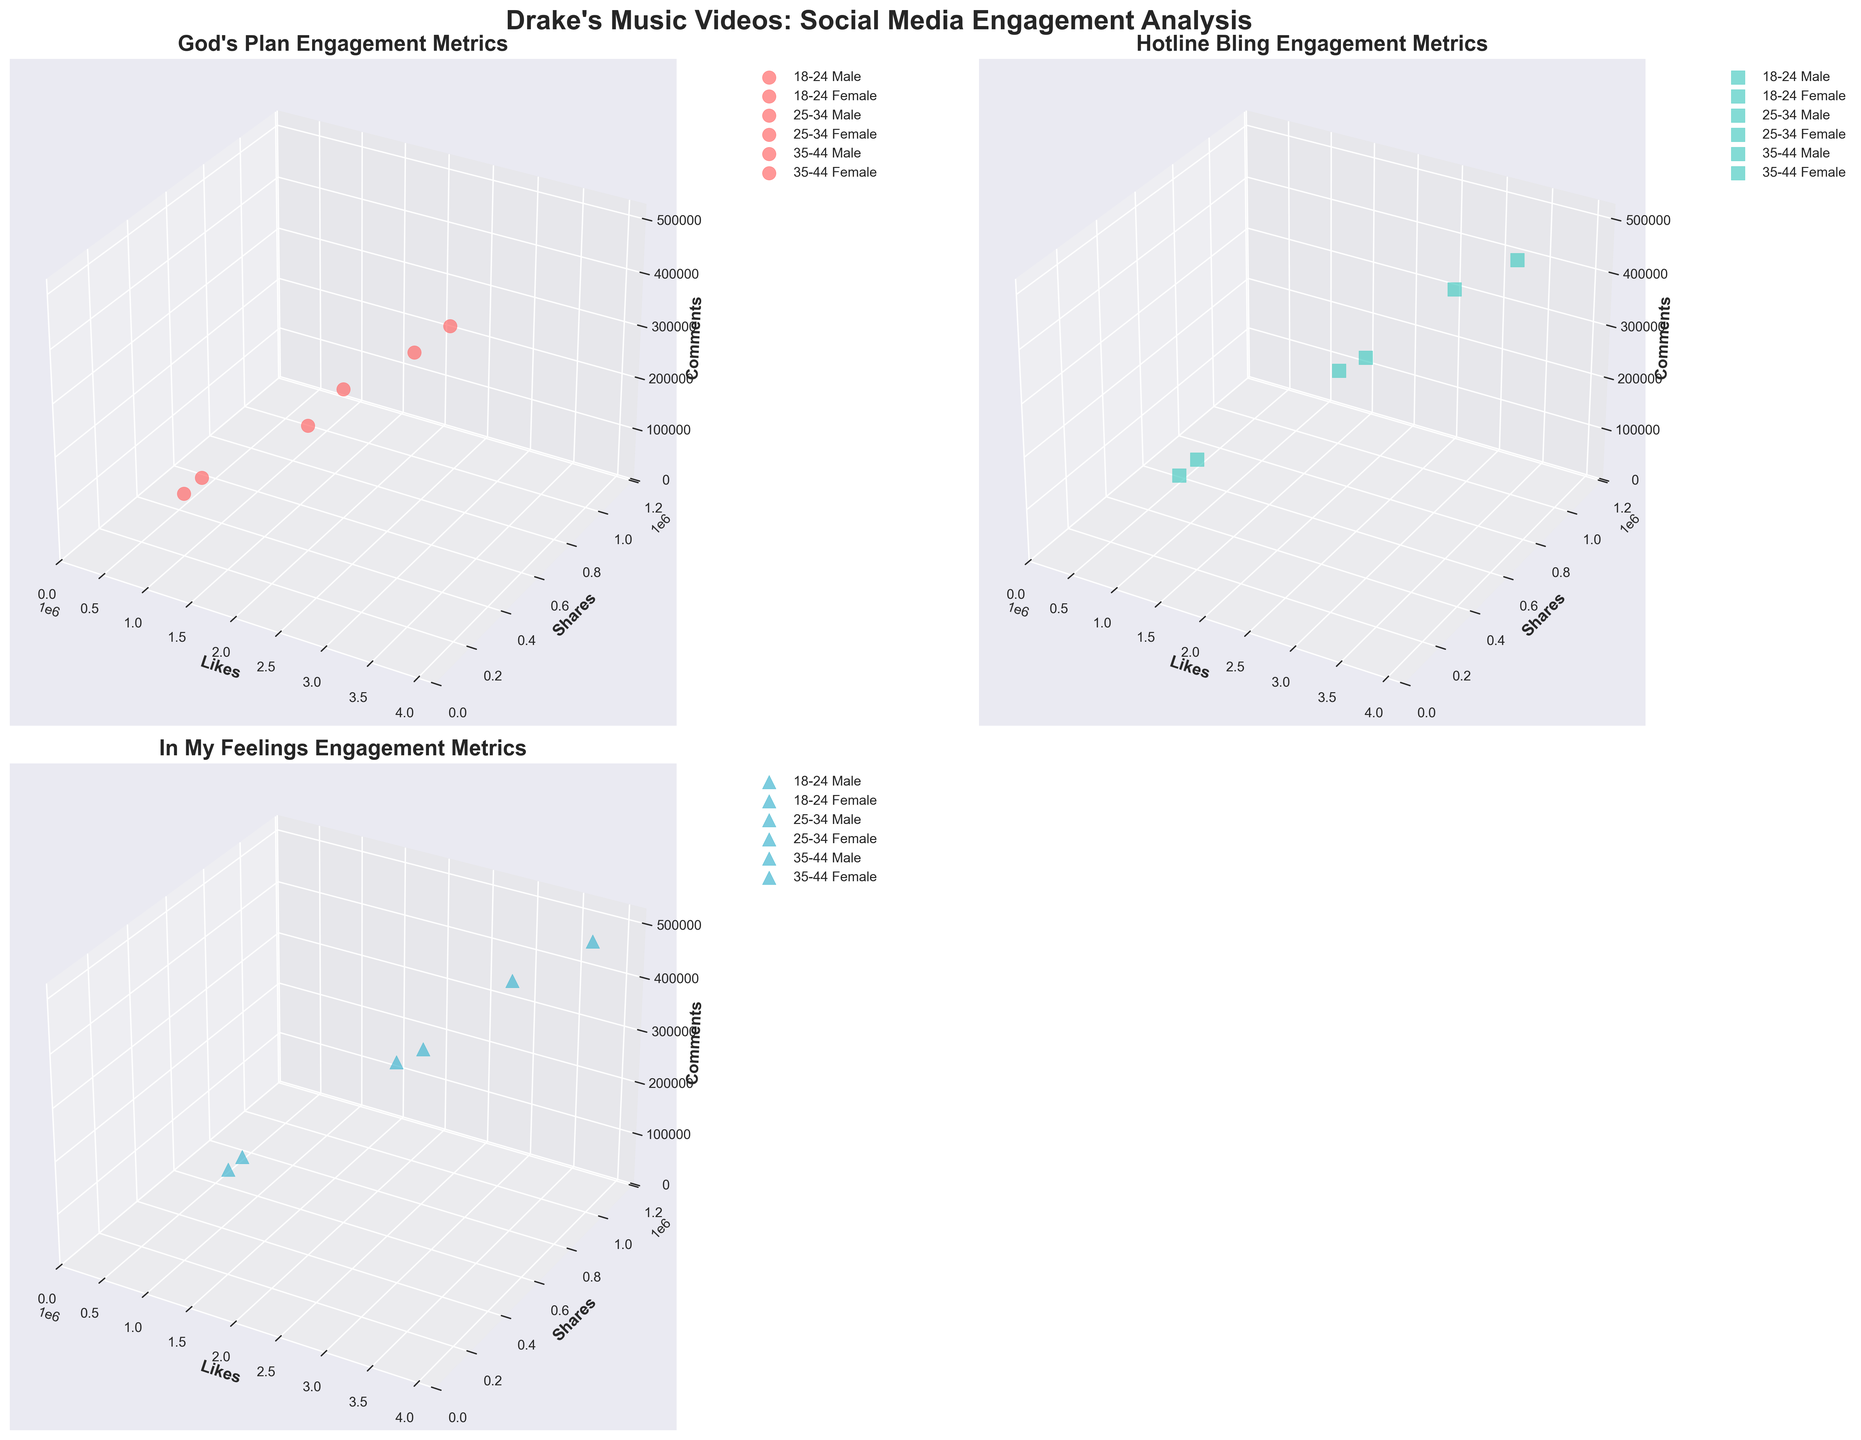What is the title of the figure? The title is usually displayed at the top of the figure as a large, bold text.
Answer: Drake's Music Videos: Social Media Engagement Analysis Which video has the highest number of likes for the 18-24 Female category? By observing each subplot, locate the 18-24 Female category points and identify the highest likes. Aggregating the highest points shows "In My Feelings" surpasses in likes.
Answer: In My Feelings How do the engagement metrics for 'Hotline Bling' differ between the 18-24 age group for males and females? Look at the 'Hotline Bling' subplot and compare the positions of the points for 18-24 Male and Female categories in terms of the Likes, Shares, and Comments axes.
Answer: Females have more Likes, Shares, and Comments Which age group and gender combination has the least engagement for 'God's Plan'? Examine the subplot for 'God's Plan' and look for the smallest values across Likes, Shares, and Comments. The least engaged combination is the point closest to the origin.
Answer: 35-44 Male What are the limits of the axes in the 'In My Feelings' plot? Check the 'In My Feelings' subplot and read the ranges indicated for each axis (Likes, Shares, Comments).
Answer: Likes: 0-3800000, Shares: 0-1100000, Comments: 0-480000 Compare the engagement metrics for 'God's Plan' between the 25-34 Male and Female categories. Locate the points for 25-34 Male and Female in the 'God's Plan' subplot and compare their positions along the Likes, Shares, and Comments axes.
Answer: Females have higher Likes, Shares, and Comments Which video has the highest engagement involving the Female gender in the 25-34 age group? By examining each subplot, specifically look for 25-34 Female points and identify the video with the highest cumulative Likes, Shares, and Comments.
Answer: In My Feelings How do the interactions vary between the 18-24 Male groups across different videos? Observe the subplots for 'God's Plan,' 'Hotline Bling,' and 'In My Feelings,' noting the positions of the 18-24 Male data points and comparing their positions.
Answer: Varies with "Hotline Bling" having the highest What is the difference in comments between the 35-44 Male and Female groups for 'Hotline Bling'? Search the 'Hotline Bling' subplot and compare the Comments axis positions for the 35-44 Male and Female points. Subtract the comments figure for males from that of females.
Answer: 20000 Which demographic has the highest shares for the 'In My Feelings' video? Locate the 'In My Feelings' subplot and identify the point with the maximum value on the Shares axis, then determine the associated demographic.
Answer: 18-24 Female 